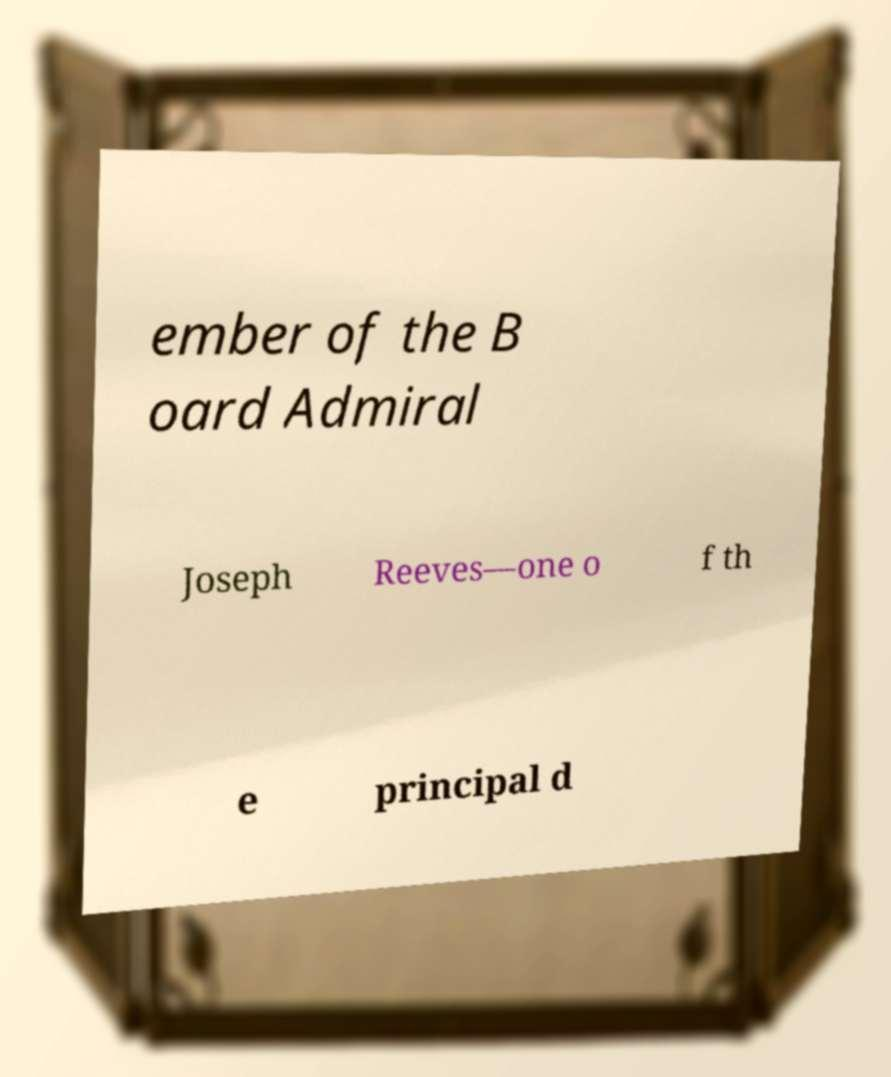Please read and relay the text visible in this image. What does it say? ember of the B oard Admiral Joseph Reeves—one o f th e principal d 